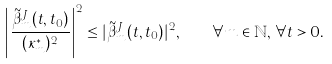<formula> <loc_0><loc_0><loc_500><loc_500>\left | \frac { \tilde { \beta } ^ { J } _ { m } ( t , t _ { 0 } ) } { ( \kappa _ { m } ^ { * } ) ^ { 2 } } \right | ^ { 2 } \leq | \tilde { \beta } ^ { J } _ { m } ( t , t _ { 0 } ) | ^ { 2 } , \quad \forall m \in \mathbb { N } , \, \forall t > 0 .</formula> 